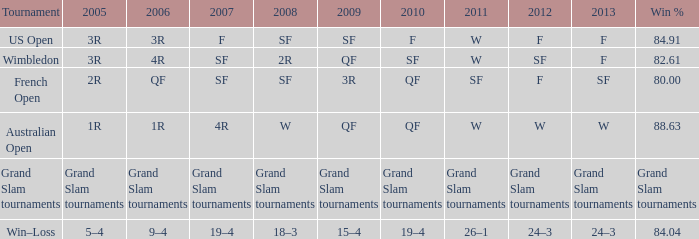Could you parse the entire table as a dict? {'header': ['Tournament', '2005', '2006', '2007', '2008', '2009', '2010', '2011', '2012', '2013', 'Win %'], 'rows': [['US Open', '3R', '3R', 'F', 'SF', 'SF', 'F', 'W', 'F', 'F', '84.91'], ['Wimbledon', '3R', '4R', 'SF', '2R', 'QF', 'SF', 'W', 'SF', 'F', '82.61'], ['French Open', '2R', 'QF', 'SF', 'SF', '3R', 'QF', 'SF', 'F', 'SF', '80.00'], ['Australian Open', '1R', '1R', '4R', 'W', 'QF', 'QF', 'W', 'W', 'W', '88.63'], ['Grand Slam tournaments', 'Grand Slam tournaments', 'Grand Slam tournaments', 'Grand Slam tournaments', 'Grand Slam tournaments', 'Grand Slam tournaments', 'Grand Slam tournaments', 'Grand Slam tournaments', 'Grand Slam tournaments', 'Grand Slam tournaments', 'Grand Slam tournaments'], ['Win–Loss', '5–4', '9–4', '19–4', '18–3', '15–4', '19–4', '26–1', '24–3', '24–3', '84.04']]} What in 2007 has a 2010 of qf, and a 2012 of w? 4R. 